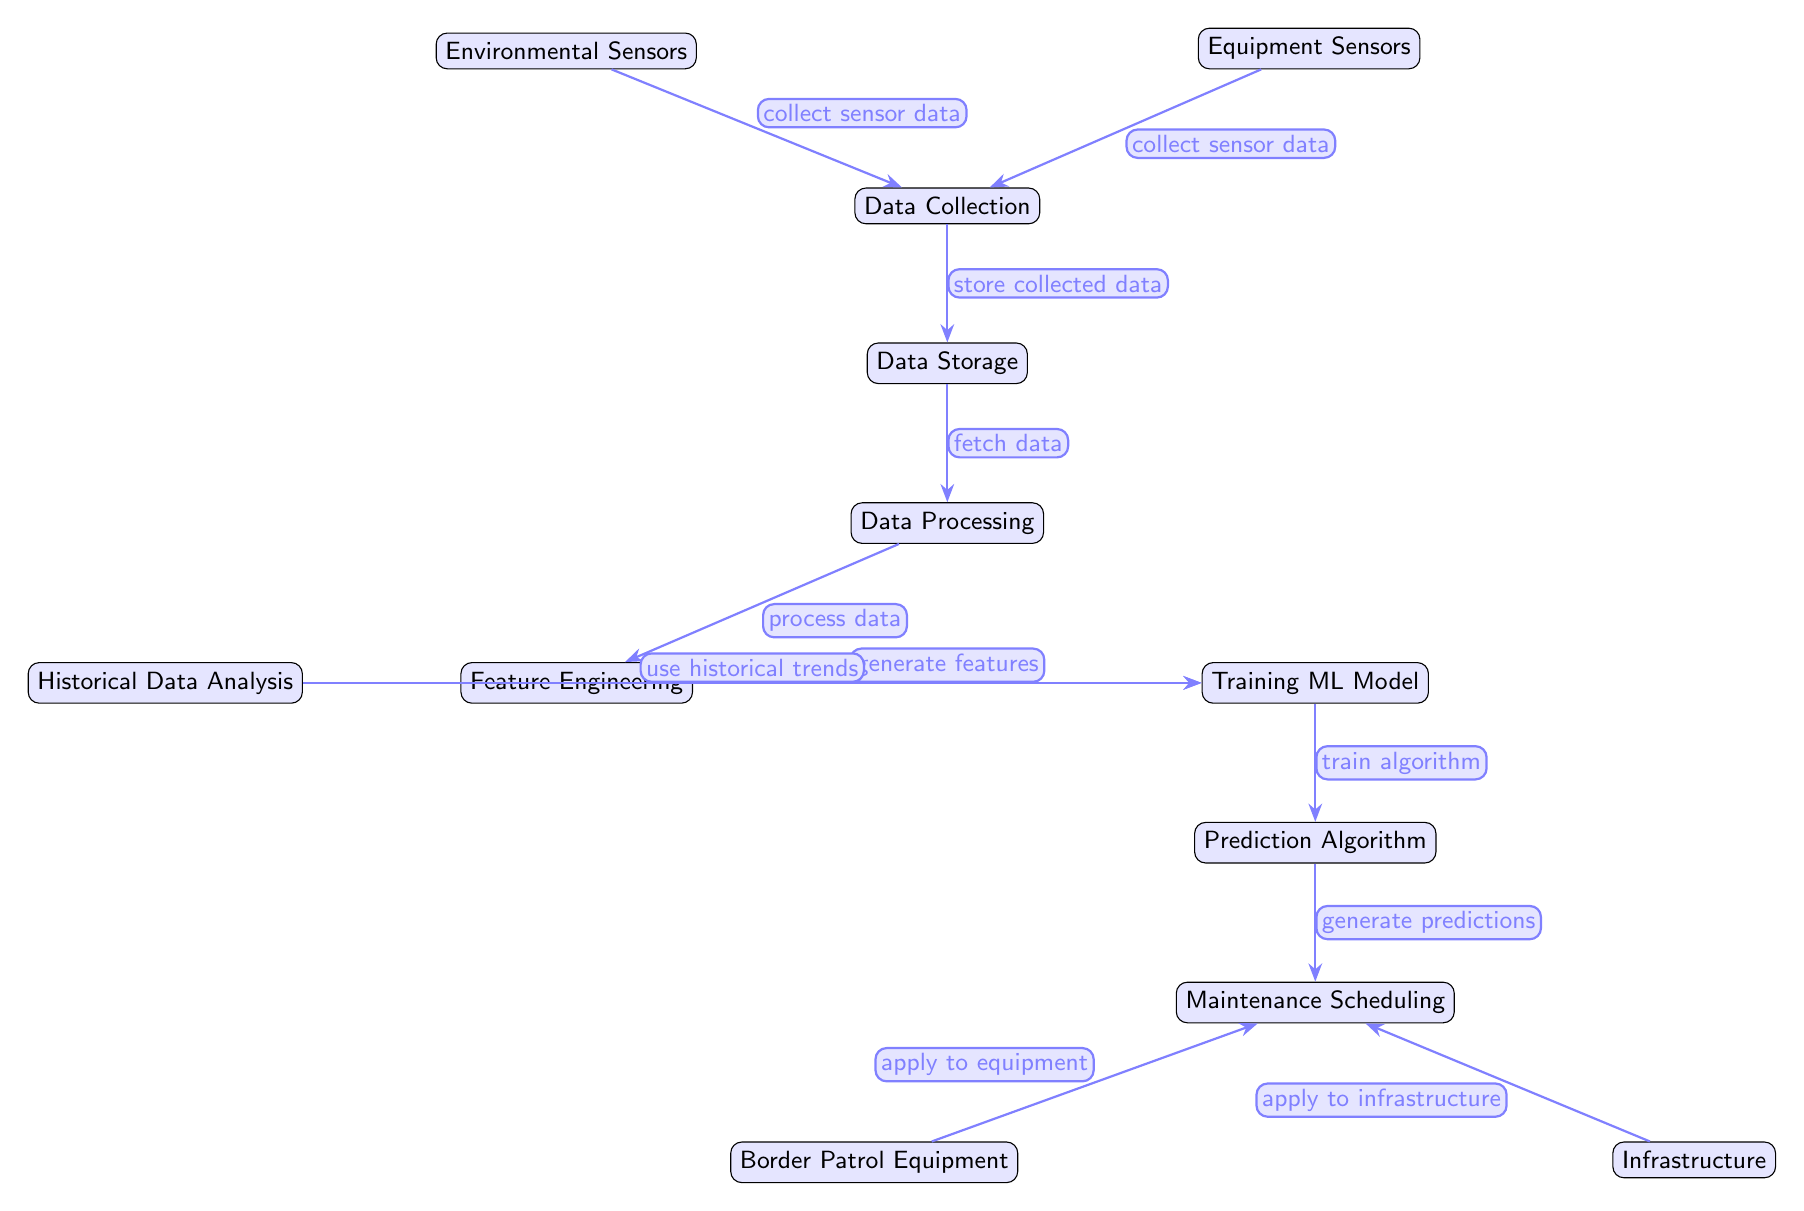What are the two types of sensors collecting data? The diagram shows two nodes: Environmental Sensors and Equipment Sensors. They both lead to the Data Collection node, indicating they are the sources of data for this process.
Answer: Environmental Sensors, Equipment Sensors How many main nodes are in the diagram? By counting all the nodes in the diagram connected by edges, we identify a total of 10 distinct nodes.
Answer: 10 What does the Data Processing node do? The edge labeled "process data" from Data Storage to Data Processing indicates that the latter is responsible for processing the data collected from sensors.
Answer: Process data Which node uses historical trends? The node Historical Data Analysis is directly connected to the Training ML Model node with an edge. This indicates that the historical trends are integrated into the training of the model.
Answer: Historical Data Analysis What is the final output of the process? The arrow labeled "generate predictions" leads from the Prediction Algorithm node to the Maintenance Scheduling node, indicating that the predictions are the end output of this diagram.
Answer: Maintenance Scheduling What nodes apply predictions to Border Patrol Equipment and Infrastructure? The Maintenance Scheduling node has two edges leading out; one goes to the Border Patrol Equipment and another to Infrastructure, indicating both are impacted by the maintenance scheduling.
Answer: Border Patrol Equipment, Infrastructure Which process comes after data collection? The edge labeled "store collected data" indicates that, immediately following data collection, the next step in the diagram is data storage.
Answer: Data Storage What node involves generating features? The diagram shows that Feature Engineering is the node directly connected to the Data Processing node, indicating that it works on generating features from the processed data.
Answer: Feature Engineering 